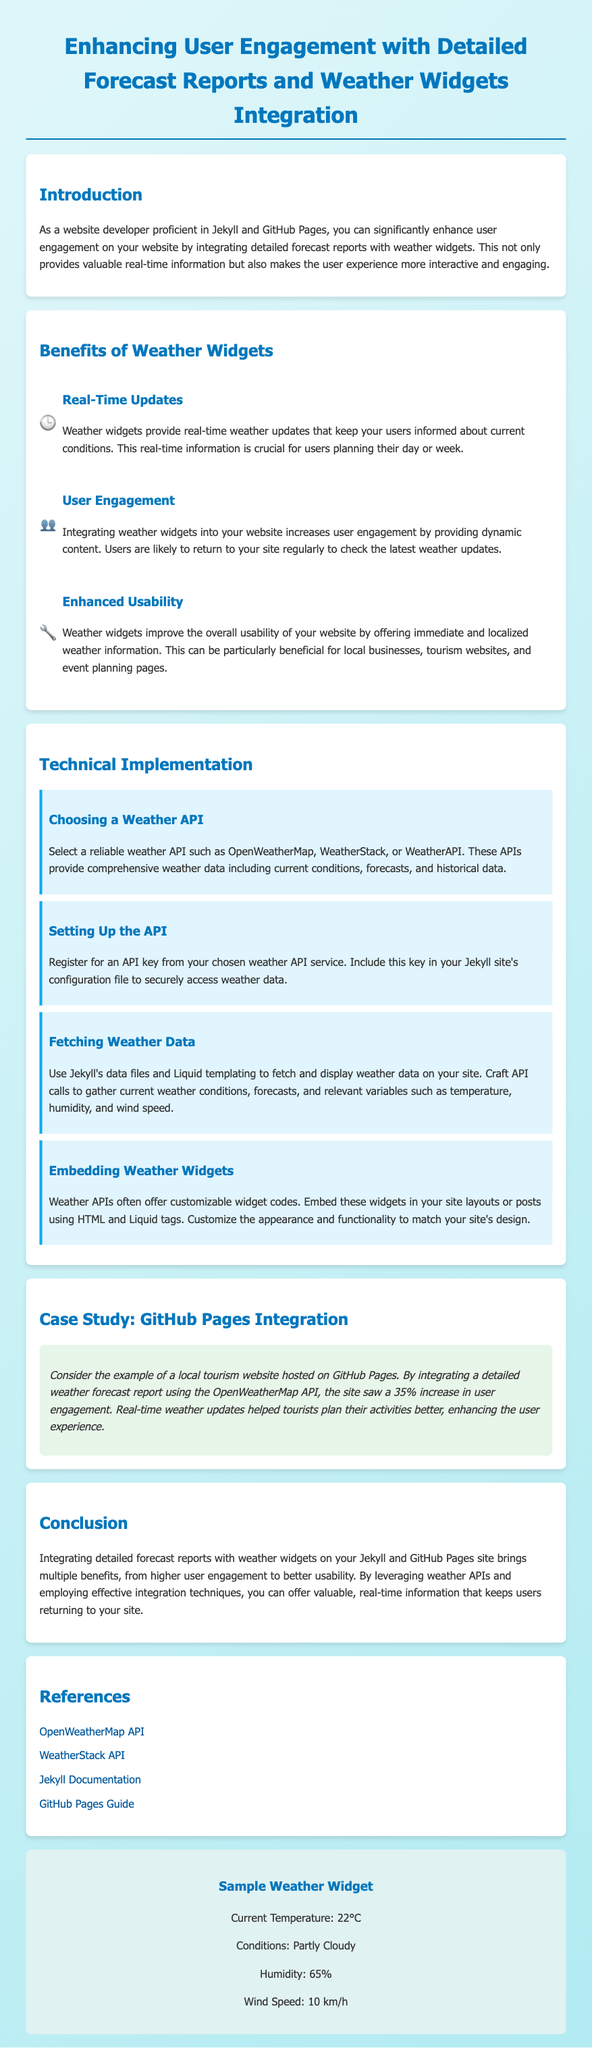what is the main topic of the document? The document focuses on integrating detailed forecast reports and weather widgets to enhance user engagement on websites.
Answer: Enhancing User Engagement with Detailed Forecast Reports and Weather Widgets Integration what are the three main benefits of weather widgets listed in the document? The document lists real-time updates, user engagement, and enhanced usability as the key benefits.
Answer: Real-Time Updates, User Engagement, Enhanced Usability which weather API example is mentioned for integration? The document mentions OpenWeatherMap as an example of a weather API for integration.
Answer: OpenWeatherMap what percentage increase in user engagement did the local tourism website achieve? The case study in the document states that the local tourism website saw a 35% increase in user engagement.
Answer: 35% what is the purpose of fetching weather data in the technical implementation section? Fetching weather data is necessary to display current weather conditions and forecasts on the site.
Answer: Display current weather conditions and forecasts which color is used for the background gradient in the document? The background gradient is described as a mix of two colors in the CSS styles, specifically light blue shades.
Answer: Light blue how should the API key be included according to the implementation? The implementation mentions including the API key in the Jekyll site's configuration file.
Answer: Jekyll site's configuration file what type of widget is displayed in the weather widget section? The weather widget section shows a sample weather widget displaying current temperature and conditions.
Answer: Sample Weather Widget 